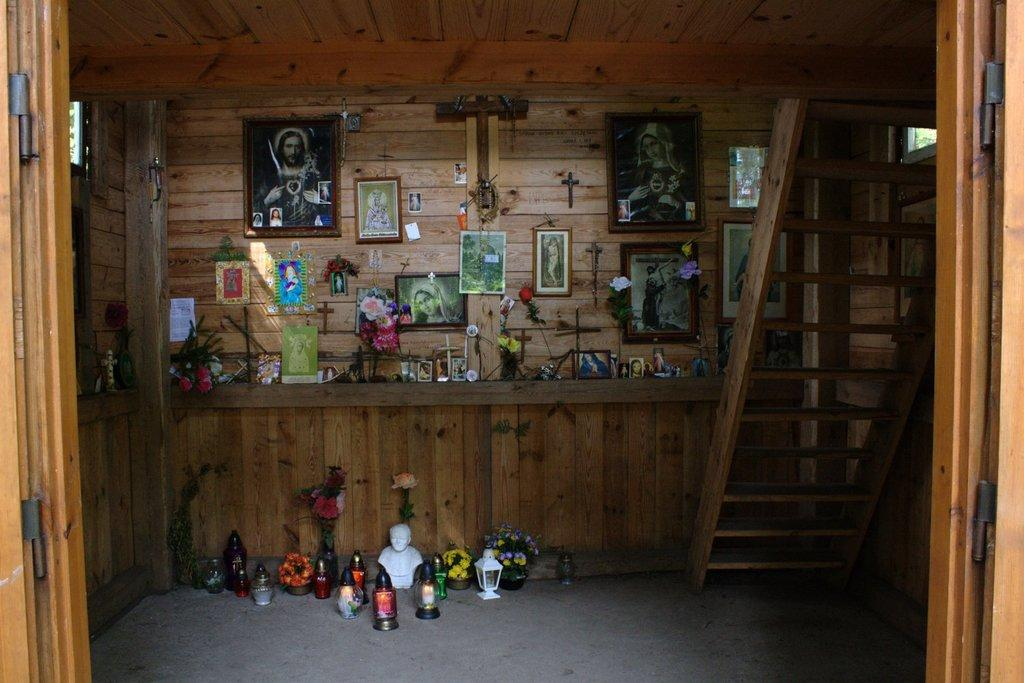Where was the image taken? The image was taken inside a room. What can be seen on the right side of the room? There are stairs on the right side of the room. What is located in the middle of the room? There are multiple photo frames and flower vases in the middle of the room. How many corks are visible in the image? There are no corks present in the image. What type of cap is worn by the person in the image? There is no person wearing a cap in the image. 